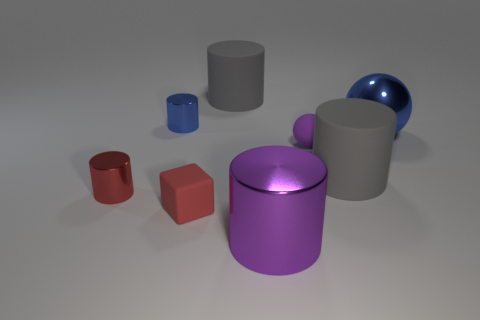Do the cylinder on the left side of the small blue cylinder and the blue sphere have the same material?
Your answer should be compact. Yes. Are there an equal number of things that are behind the small red shiny thing and small metallic objects?
Offer a terse response. No. The blue ball is what size?
Your response must be concise. Large. There is a small ball that is the same color as the large metal cylinder; what is it made of?
Give a very brief answer. Rubber. How many tiny cylinders are the same color as the large metallic ball?
Make the answer very short. 1. Is the purple metal object the same size as the red cube?
Keep it short and to the point. No. What is the size of the blue metallic thing that is on the right side of the purple metallic object that is in front of the small red rubber thing?
Offer a terse response. Large. Do the small cube and the small metal cylinder in front of the blue metallic ball have the same color?
Your answer should be compact. Yes. Is there another cylinder that has the same size as the red metal cylinder?
Give a very brief answer. Yes. How big is the gray rubber cylinder in front of the big metal sphere?
Provide a short and direct response. Large. 